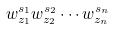<formula> <loc_0><loc_0><loc_500><loc_500>w _ { z _ { 1 } } ^ { s _ { 1 } } w _ { z _ { 2 } } ^ { s _ { 2 } } \cdots w _ { z _ { n } } ^ { s _ { n } }</formula> 